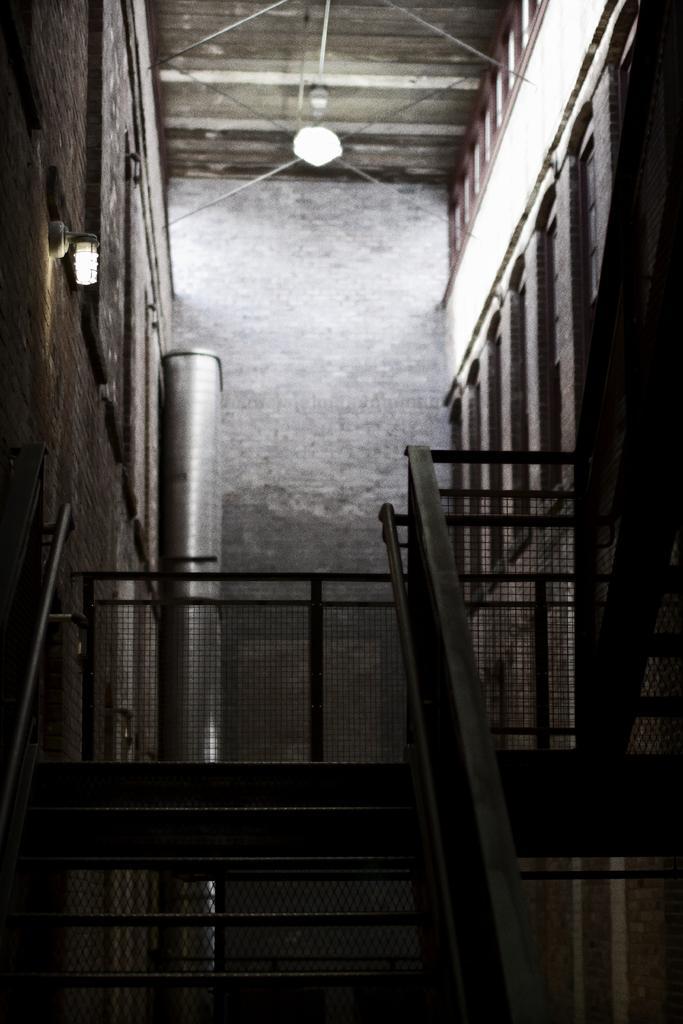Describe this image in one or two sentences. In the foreground of this image, there are stairs, railing, wall and the lights. We can also see a metal pipe like an object. 